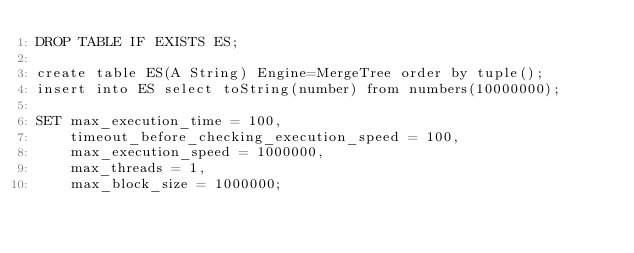<code> <loc_0><loc_0><loc_500><loc_500><_SQL_>DROP TABLE IF EXISTS ES;

create table ES(A String) Engine=MergeTree order by tuple();
insert into ES select toString(number) from numbers(10000000);

SET max_execution_time = 100,
    timeout_before_checking_execution_speed = 100,
    max_execution_speed = 1000000,
    max_threads = 1,
    max_block_size = 1000000;
</code> 